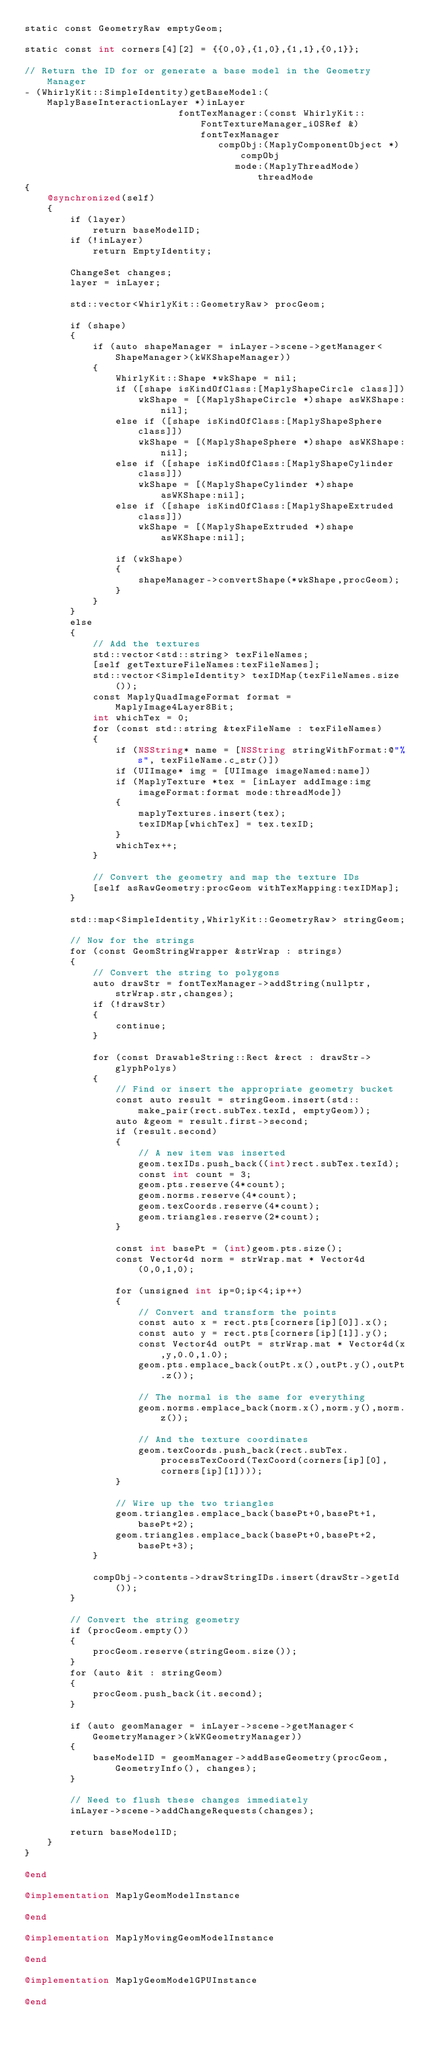Convert code to text. <code><loc_0><loc_0><loc_500><loc_500><_ObjectiveC_>static const GeometryRaw emptyGeom;

static const int corners[4][2] = {{0,0},{1,0},{1,1},{0,1}};

// Return the ID for or generate a base model in the Geometry Manager
- (WhirlyKit::SimpleIdentity)getBaseModel:(MaplyBaseInteractionLayer *)inLayer
                           fontTexManager:(const WhirlyKit::FontTextureManager_iOSRef &)fontTexManager
                                  compObj:(MaplyComponentObject *)compObj
                                     mode:(MaplyThreadMode)threadMode
{
    @synchronized(self)
    {
        if (layer)
            return baseModelID;
        if (!inLayer)
            return EmptyIdentity;

        ChangeSet changes;
        layer = inLayer;
        
        std::vector<WhirlyKit::GeometryRaw> procGeom;
        
        if (shape)
        {
            if (auto shapeManager = inLayer->scene->getManager<ShapeManager>(kWKShapeManager))
            {
                WhirlyKit::Shape *wkShape = nil;
                if ([shape isKindOfClass:[MaplyShapeCircle class]])
                    wkShape = [(MaplyShapeCircle *)shape asWKShape:nil];
                else if ([shape isKindOfClass:[MaplyShapeSphere class]])
                    wkShape = [(MaplyShapeSphere *)shape asWKShape:nil];
                else if ([shape isKindOfClass:[MaplyShapeCylinder class]])
                    wkShape = [(MaplyShapeCylinder *)shape asWKShape:nil];
                else if ([shape isKindOfClass:[MaplyShapeExtruded class]])
                    wkShape = [(MaplyShapeExtruded *)shape asWKShape:nil];

                if (wkShape)
                {
                    shapeManager->convertShape(*wkShape,procGeom);
                }
            }
        }
        else
        {
            // Add the textures
            std::vector<std::string> texFileNames;
            [self getTextureFileNames:texFileNames];
            std::vector<SimpleIdentity> texIDMap(texFileNames.size());
            const MaplyQuadImageFormat format = MaplyImage4Layer8Bit;
            int whichTex = 0;
            for (const std::string &texFileName : texFileNames)
            {
                if (NSString* name = [NSString stringWithFormat:@"%s", texFileName.c_str()])
                if (UIImage* img = [UIImage imageNamed:name])
                if (MaplyTexture *tex = [inLayer addImage:img imageFormat:format mode:threadMode])
                {
                    maplyTextures.insert(tex);
                    texIDMap[whichTex] = tex.texID;
                }
                whichTex++;
            }
            
            // Convert the geometry and map the texture IDs
            [self asRawGeometry:procGeom withTexMapping:texIDMap];
        }
        
        std::map<SimpleIdentity,WhirlyKit::GeometryRaw> stringGeom;
        
        // Now for the strings
        for (const GeomStringWrapper &strWrap : strings)
        {
            // Convert the string to polygons
            auto drawStr = fontTexManager->addString(nullptr,strWrap.str,changes);
            if (!drawStr)
            {
                continue;
            }

            for (const DrawableString::Rect &rect : drawStr->glyphPolys)
            {
                // Find or insert the appropriate geometry bucket
                const auto result = stringGeom.insert(std::make_pair(rect.subTex.texId, emptyGeom));
                auto &geom = result.first->second;
                if (result.second)
                {
                    // A new item was inserted
                    geom.texIDs.push_back((int)rect.subTex.texId);
                    const int count = 3;
                    geom.pts.reserve(4*count);
                    geom.norms.reserve(4*count);
                    geom.texCoords.reserve(4*count);
                    geom.triangles.reserve(2*count);
                }

                const int basePt = (int)geom.pts.size();
                const Vector4d norm = strWrap.mat * Vector4d(0,0,1,0);

                for (unsigned int ip=0;ip<4;ip++)
                {
                    // Convert and transform the points
                    const auto x = rect.pts[corners[ip][0]].x();
                    const auto y = rect.pts[corners[ip][1]].y();
                    const Vector4d outPt = strWrap.mat * Vector4d(x,y,0.0,1.0);
                    geom.pts.emplace_back(outPt.x(),outPt.y(),outPt.z());

                    // The normal is the same for everything
                    geom.norms.emplace_back(norm.x(),norm.y(),norm.z());

                    // And the texture coordinates
                    geom.texCoords.push_back(rect.subTex.processTexCoord(TexCoord(corners[ip][0],corners[ip][1])));
                }

                // Wire up the two triangles
                geom.triangles.emplace_back(basePt+0,basePt+1,basePt+2);
                geom.triangles.emplace_back(basePt+0,basePt+2,basePt+3);
            }

            compObj->contents->drawStringIDs.insert(drawStr->getId());
        }
        
        // Convert the string geometry
        if (procGeom.empty())
        {
            procGeom.reserve(stringGeom.size());
        }
        for (auto &it : stringGeom)
        {
            procGeom.push_back(it.second);
        }

        if (auto geomManager = inLayer->scene->getManager<GeometryManager>(kWKGeometryManager))
        {
            baseModelID = geomManager->addBaseGeometry(procGeom, GeometryInfo(), changes);
        }

        // Need to flush these changes immediately
        inLayer->scene->addChangeRequests(changes);
        
        return baseModelID;
    }
}

@end

@implementation MaplyGeomModelInstance

@end

@implementation MaplyMovingGeomModelInstance

@end

@implementation MaplyGeomModelGPUInstance

@end

</code> 